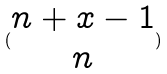Convert formula to latex. <formula><loc_0><loc_0><loc_500><loc_500>( \begin{matrix} n + x - 1 \\ n \end{matrix} )</formula> 